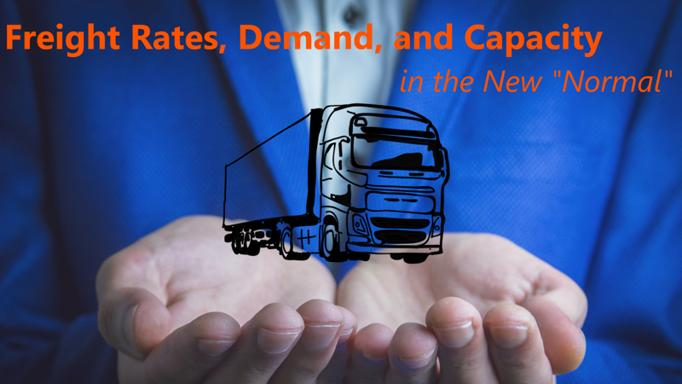What adjustments do trucking companies need to make in the 'New Normal' regarding their fleet? In the 'New Normal,' trucking companies must make strategic adjustments to their fleet management, focusing on optimizing route planning using advanced technologies, investing in fuel-efficient and environmentally friendly vehicles, and enhancing driver training programs to improve efficiency and adapt to new regulations and market demands. 